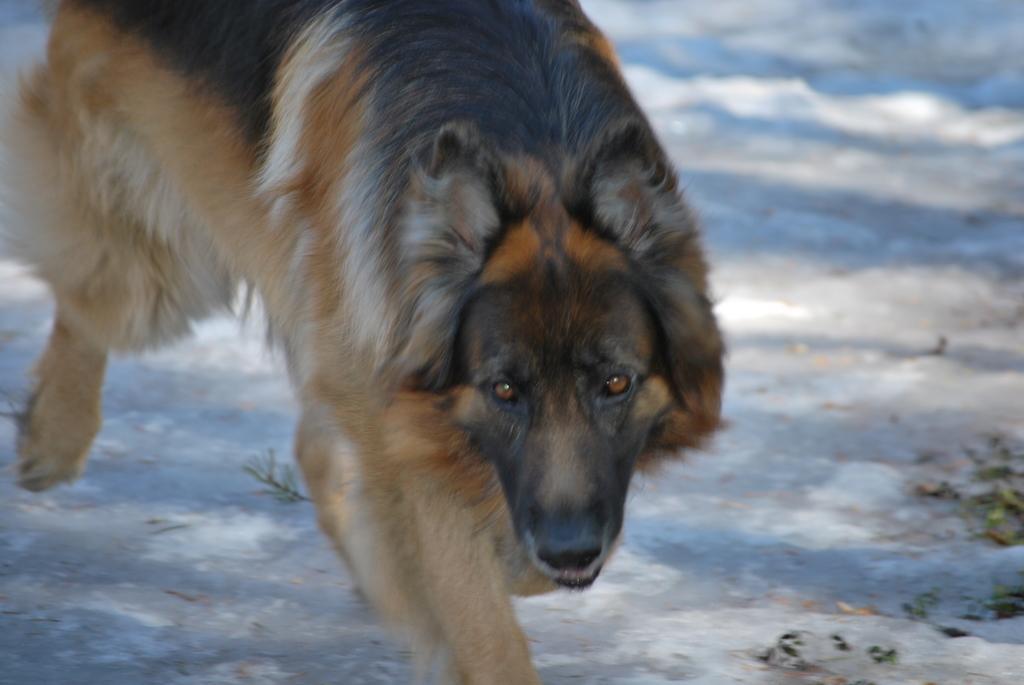How would you summarize this image in a sentence or two? In this image I can see a dog walking in snow. 